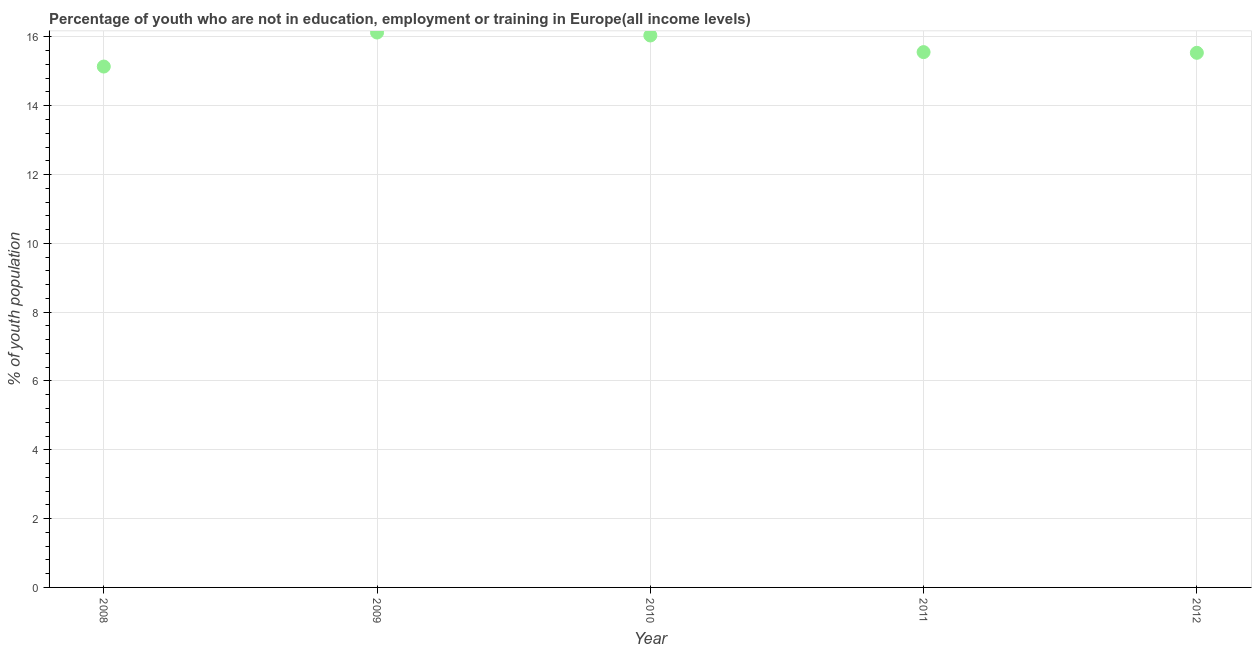What is the unemployed youth population in 2009?
Make the answer very short. 16.13. Across all years, what is the maximum unemployed youth population?
Ensure brevity in your answer.  16.13. Across all years, what is the minimum unemployed youth population?
Provide a succinct answer. 15.14. What is the sum of the unemployed youth population?
Ensure brevity in your answer.  78.4. What is the difference between the unemployed youth population in 2010 and 2012?
Ensure brevity in your answer.  0.5. What is the average unemployed youth population per year?
Provide a short and direct response. 15.68. What is the median unemployed youth population?
Your response must be concise. 15.56. In how many years, is the unemployed youth population greater than 2.8 %?
Offer a very short reply. 5. Do a majority of the years between 2010 and 2008 (inclusive) have unemployed youth population greater than 7.2 %?
Provide a short and direct response. No. What is the ratio of the unemployed youth population in 2009 to that in 2012?
Offer a very short reply. 1.04. What is the difference between the highest and the second highest unemployed youth population?
Your answer should be very brief. 0.09. Is the sum of the unemployed youth population in 2008 and 2011 greater than the maximum unemployed youth population across all years?
Provide a short and direct response. Yes. What is the difference between the highest and the lowest unemployed youth population?
Your answer should be very brief. 0.99. In how many years, is the unemployed youth population greater than the average unemployed youth population taken over all years?
Your response must be concise. 2. Does the unemployed youth population monotonically increase over the years?
Ensure brevity in your answer.  No. How many years are there in the graph?
Offer a very short reply. 5. Are the values on the major ticks of Y-axis written in scientific E-notation?
Your answer should be compact. No. Does the graph contain grids?
Your answer should be very brief. Yes. What is the title of the graph?
Give a very brief answer. Percentage of youth who are not in education, employment or training in Europe(all income levels). What is the label or title of the Y-axis?
Your answer should be compact. % of youth population. What is the % of youth population in 2008?
Give a very brief answer. 15.14. What is the % of youth population in 2009?
Make the answer very short. 16.13. What is the % of youth population in 2010?
Keep it short and to the point. 16.04. What is the % of youth population in 2011?
Keep it short and to the point. 15.56. What is the % of youth population in 2012?
Offer a very short reply. 15.54. What is the difference between the % of youth population in 2008 and 2009?
Provide a succinct answer. -0.99. What is the difference between the % of youth population in 2008 and 2010?
Your answer should be very brief. -0.9. What is the difference between the % of youth population in 2008 and 2011?
Provide a succinct answer. -0.42. What is the difference between the % of youth population in 2008 and 2012?
Keep it short and to the point. -0.4. What is the difference between the % of youth population in 2009 and 2010?
Offer a very short reply. 0.09. What is the difference between the % of youth population in 2009 and 2011?
Provide a succinct answer. 0.57. What is the difference between the % of youth population in 2009 and 2012?
Make the answer very short. 0.59. What is the difference between the % of youth population in 2010 and 2011?
Your response must be concise. 0.48. What is the difference between the % of youth population in 2010 and 2012?
Make the answer very short. 0.5. What is the difference between the % of youth population in 2011 and 2012?
Provide a succinct answer. 0.02. What is the ratio of the % of youth population in 2008 to that in 2009?
Your response must be concise. 0.94. What is the ratio of the % of youth population in 2008 to that in 2010?
Your answer should be very brief. 0.94. What is the ratio of the % of youth population in 2009 to that in 2010?
Keep it short and to the point. 1. What is the ratio of the % of youth population in 2009 to that in 2011?
Your answer should be very brief. 1.04. What is the ratio of the % of youth population in 2009 to that in 2012?
Your answer should be very brief. 1.04. What is the ratio of the % of youth population in 2010 to that in 2011?
Provide a short and direct response. 1.03. What is the ratio of the % of youth population in 2010 to that in 2012?
Offer a very short reply. 1.03. What is the ratio of the % of youth population in 2011 to that in 2012?
Offer a very short reply. 1. 